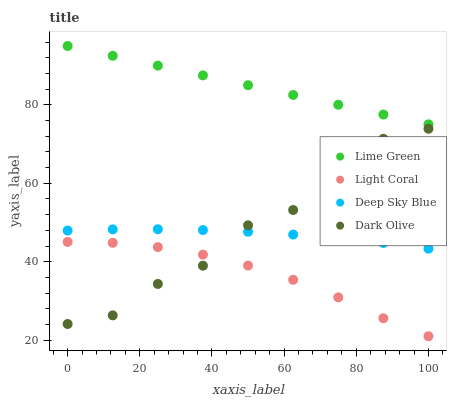Does Light Coral have the minimum area under the curve?
Answer yes or no. Yes. Does Lime Green have the maximum area under the curve?
Answer yes or no. Yes. Does Dark Olive have the minimum area under the curve?
Answer yes or no. No. Does Dark Olive have the maximum area under the curve?
Answer yes or no. No. Is Lime Green the smoothest?
Answer yes or no. Yes. Is Dark Olive the roughest?
Answer yes or no. Yes. Is Dark Olive the smoothest?
Answer yes or no. No. Is Lime Green the roughest?
Answer yes or no. No. Does Light Coral have the lowest value?
Answer yes or no. Yes. Does Dark Olive have the lowest value?
Answer yes or no. No. Does Lime Green have the highest value?
Answer yes or no. Yes. Does Dark Olive have the highest value?
Answer yes or no. No. Is Deep Sky Blue less than Lime Green?
Answer yes or no. Yes. Is Lime Green greater than Dark Olive?
Answer yes or no. Yes. Does Dark Olive intersect Light Coral?
Answer yes or no. Yes. Is Dark Olive less than Light Coral?
Answer yes or no. No. Is Dark Olive greater than Light Coral?
Answer yes or no. No. Does Deep Sky Blue intersect Lime Green?
Answer yes or no. No. 